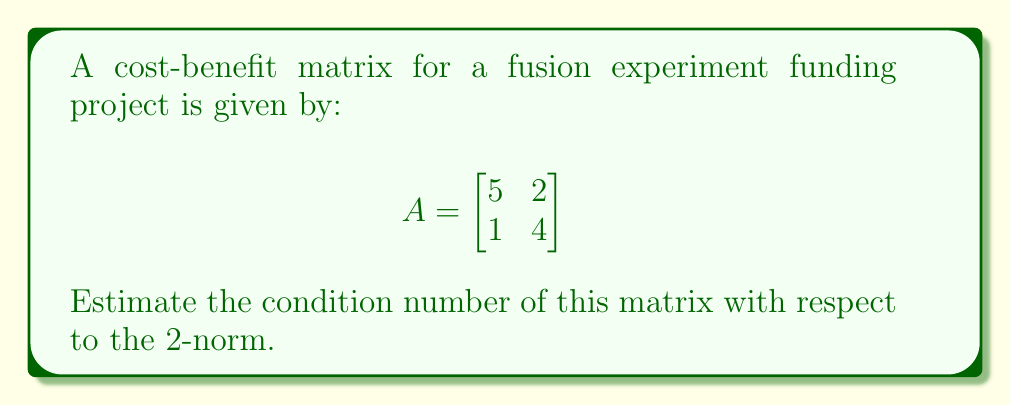Give your solution to this math problem. To estimate the condition number of matrix $A$ with respect to the 2-norm, we follow these steps:

1) The condition number is defined as:
   $$\kappa(A) = \|A\| \cdot \|A^{-1}\|$$
   where $\|\cdot\|$ denotes the 2-norm (spectral norm) of a matrix.

2) For a 2x2 matrix, the 2-norm is equal to the largest singular value, which is the square root of the largest eigenvalue of $A^TA$.

3) Calculate $A^TA$:
   $$A^TA = \begin{bmatrix}
   5 & 1 \\
   2 & 4
   \end{bmatrix} \begin{bmatrix}
   5 & 2 \\
   1 & 4
   \end{bmatrix} = \begin{bmatrix}
   26 & 14 \\
   14 & 20
   \end{bmatrix}$$

4) Find the eigenvalues of $A^TA$:
   $\det(A^TA - \lambda I) = \begin{vmatrix}
   26-\lambda & 14 \\
   14 & 20-\lambda
   \end{vmatrix} = (26-\lambda)(20-\lambda) - 196 = \lambda^2 - 46\lambda + 324 = 0$

   Solving this quadratic equation, we get $\lambda_1 \approx 41.81$ and $\lambda_2 \approx 4.19$

5) The largest singular value (and thus $\|A\|_2$) is $\sqrt{41.81} \approx 6.47$

6) To find $\|A^{-1}\|_2$, we first calculate $A^{-1}$:
   $$A^{-1} = \frac{1}{5\cdot4 - 2\cdot1} \begin{bmatrix}
   4 & -2 \\
   -1 & 5
   \end{bmatrix} = \frac{1}{18} \begin{bmatrix}
   4 & -2 \\
   -1 & 5
   \end{bmatrix}$$

7) Repeat steps 3-5 for $A^{-1}$ to find $\|A^{-1}\|_2 \approx 0.31$

8) The condition number is thus:
   $$\kappa(A) = \|A\|_2 \cdot \|A^{-1}\|_2 \approx 6.47 \cdot 0.31 \approx 2.01$$
Answer: $\kappa(A) \approx 2.01$ 